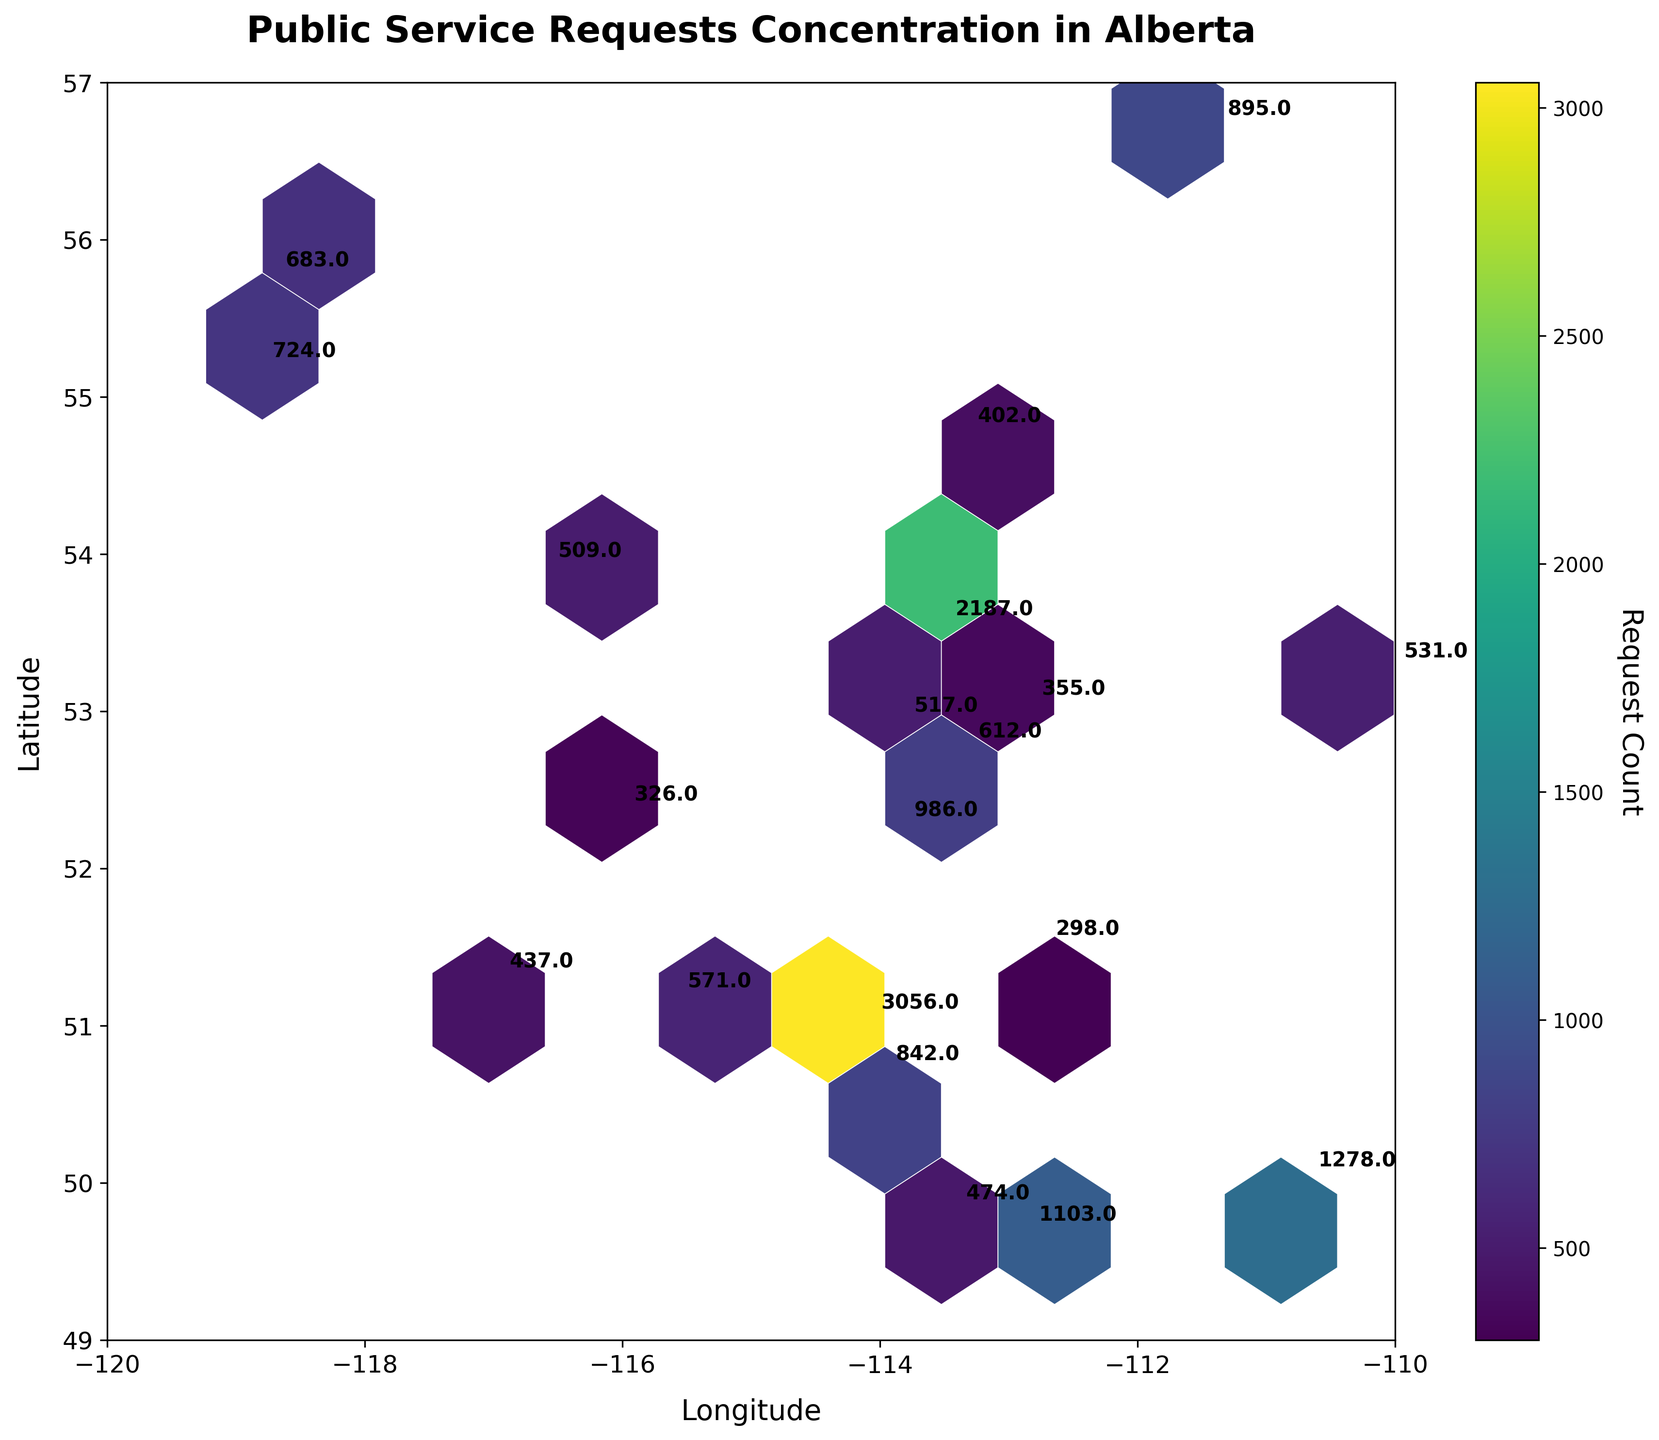What is the title of the hexbin plot? The title of a hexbin plot is usually displayed at the top of the figure. Here, the hexbin plot has the title "Public Service Requests Concentration in Alberta."
Answer: Public Service Requests Concentration in Alberta What are the axis labels? The axis labels are textual descriptions provided along the axes to explain what data points represent. The x-axis is labeled "Longitude" and the y-axis is labeled "Latitude."
Answer: Longitude and Latitude What color scheme is used in the hexbin plot? The color scheme used helps to visualize the concentration of public service requests. The plot uses the 'viridis' colormap, which ranges from shades of purple for lower values to shades of yellow for higher values.
Answer: viridis How many data points are there in the plot? Each pair of Latitude and Longitude with associated RequestCount represents a data point. The dataset includes 20 data points on the hexbin plot.
Answer: 20 Which municipality has the highest Request Count? The municipality with the highest Request Count can be identified by looking for the highest value in the plot annotations. Calgary, located at (51.0447, -114.0719), has a Request Count of 3056.
Answer: Calgary What is the median Request Count value for these municipalities? To find the median, list all RequestCount values and find the middle value after sorting them. The RequestCounts are [326, 355, 402, 437, 474, 509, 517, 531, 571, 612, 683, 724, 842, 895, 986, 1103, 1278, 2187, 3056]. The median value lies between the 10th and 11th values: (612+683)/2 = 647.5.
Answer: 647.5 Compare the Request Counts between Edmonton and Medicine Hat. Which one has more requests? By locating Edmonton (53.5461, -113.4938) with a Request Count of 2187 and Medicine Hat (50.0419, -110.6768) with a Request Count of 1278, it is clear Edmonton has more requests.
Answer: Edmonton What does the color intensity indicate in this hexbin plot? In a hexbin plot, color intensity indicates the concentration of data points in that area. Darker colors (e.g., purple) represent lower concentrations and lighter colors (e.g., yellow) indicate higher concentrations of service requests.
Answer: Concentration What is the approximate range for Request Counts shown by the color bar? The color bar, usually to the side of the hexbin plot, represents the range of Request Counts. From the plot, it seems to range from around 300 to over 3000.
Answer: 300 to 3000 